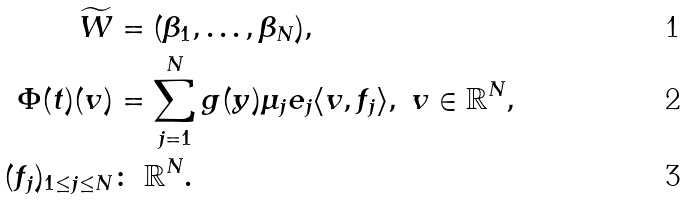<formula> <loc_0><loc_0><loc_500><loc_500>\widetilde { W } & = ( \beta _ { 1 } , \dots , \beta _ { N } ) , \\ \Phi ( t ) ( v ) & = \sum _ { j = 1 } ^ { N } g ( y ) \mu _ { j } e _ { j } \langle v , f _ { j } \rangle , \ v \in \mathbb { R } ^ { N } , \\ ( f _ { j } ) _ { 1 \leq j \leq N } & \colon \ \mathbb { R } ^ { N } .</formula> 